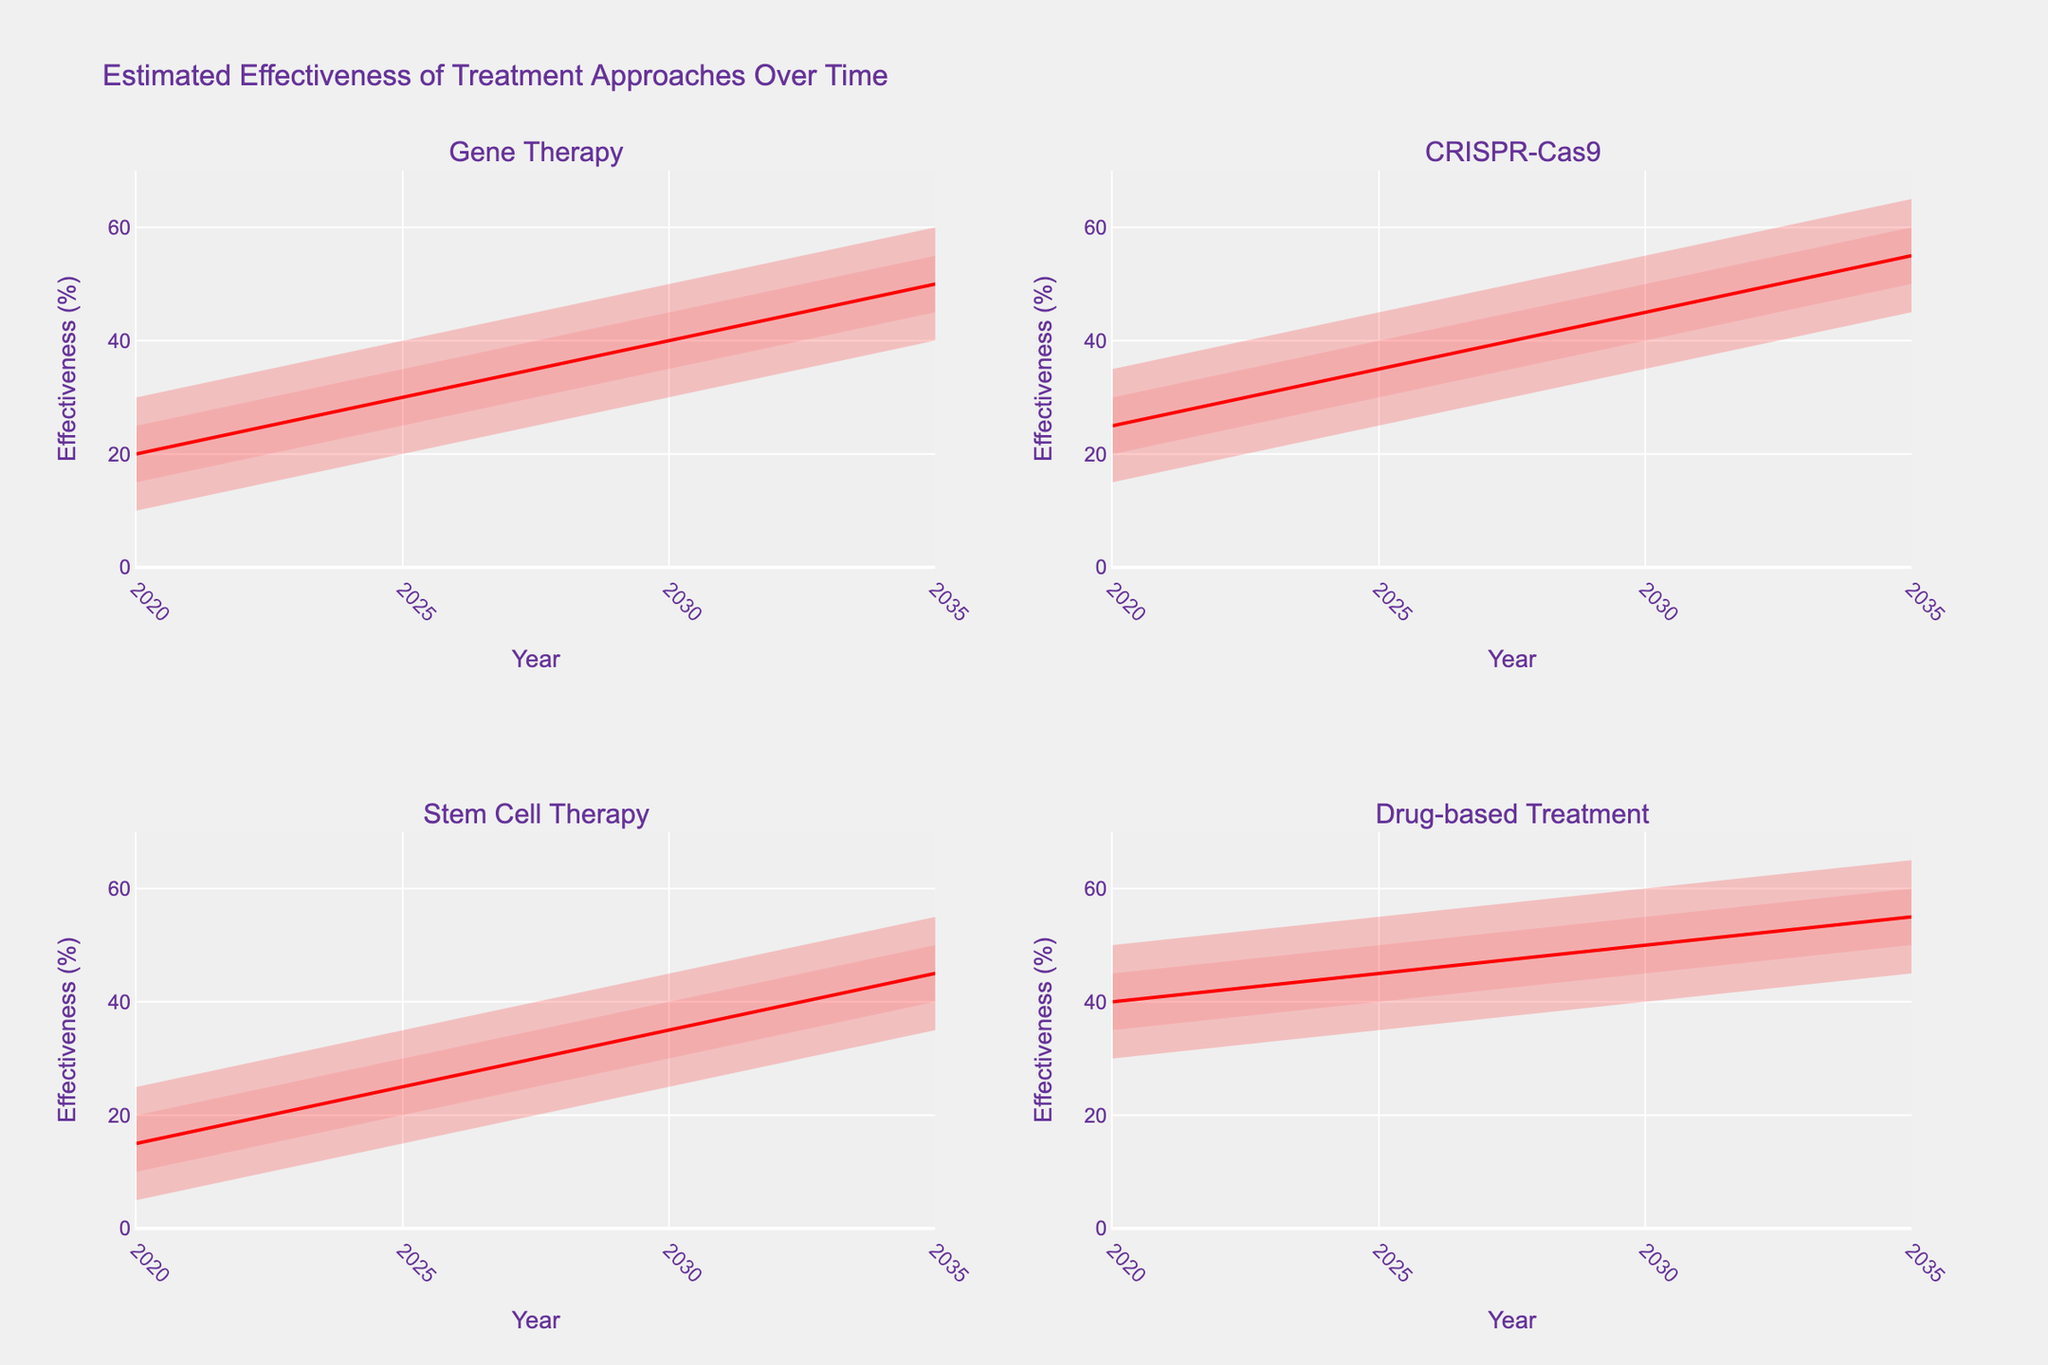What is the title of the chart? The title of the chart is displayed at the top center of the figure.
Answer: Estimated Effectiveness of Treatment Approaches Over Time Which treatment approach shows the highest estimated effectiveness in 2025? In 2025, look at the subplots and observe the highest range for each treatment's effectiveness. The highest range for CRISPR-Cas9 in 2025 goes up to 45%.
Answer: CRISPR-Cas9 How do the estimated effectiveness ranges for Gene Therapy and Drug-based Treatment compare in 2030? Examine the top (High) and bottom (Low) endpoints of the effectiveness ranges for both Gene Therapy and Drug-based Treatment in 2030. Gene Therapy ranges from 30% to 50%, while Drug-based Treatment ranges from 40% to 60%.
Answer: Drug-based Treatment is higher What is the average mid-value effectiveness estimated for Stem Cell Therapy across all years? Calculate the Mid value for Stem Cell Therapy in each year (15% in 2020, 25% in 2025, 35% in 2030, and 45% in 2035), then find the average. (15+25+35+45)/4
Answer: 30% Which treatment shows the largest increase in mid-value effectiveness from 2020 to 2035? Subtract the Mid value in 2020 from the Mid value in 2035 for each treatment. Gene Therapy: (50-20)=30, CRISPR-Cas9: (55-25)=30, Stem Cell Therapy: (45-15)=30, Drug-based Treatment: (55-40)=15. Gene Therapy, CRISPR-Cas9, and Stem Cell Therapy each have the largest increase of 30%.
Answer: Gene Therapy, CRISPR-Cas9, and Stem Cell Therapy What are the visualization colors used to represent the confidence intervals for effectiveness? The confidence intervals are visualized using different shades of red. The outermost regions are darkest red, then lighter red, and the innermost region is the lightest red.
Answer: Various shades of red How does the estimated effectiveness of CRISPR-Cas9 in 2020 compare to that of Gene Therapy? Examine the ranges for both treatments in 2020. CRISPR-Cas9 ranges from 15% to 35%, while Gene Therapy ranges from 10% to 30%.
Answer: Higher During which year do all treatments show an overlap in their estimated effectiveness ranges? Identify a year where all the subplots show overlapping effectiveness values. In 2025, the ranges for all treatments intersect between 25-35%.
Answer: 2025 What is the trend of Drug-based Treatment effectiveness from 2020 to 2035? Observing the Drug-based Treatment subplot, the Low, Low-Mid, Mid, Mid-High, and High values all increase over time.
Answer: Increasing For the year 2035, arrange the treatments in descending order of their top (High) estimated effectiveness value. Compare the High value in 2035 for all treatments. CRISPR-Cas9: 65%, Drug-based Treatment: 65%, Gene Therapy: 60%, Stem Cell Therapy: 55%.
Answer: CRISPR-Cas9, Drug-based Treatment, Gene Therapy, Stem Cell Therapy 